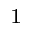<formula> <loc_0><loc_0><loc_500><loc_500>^ { 1 }</formula> 